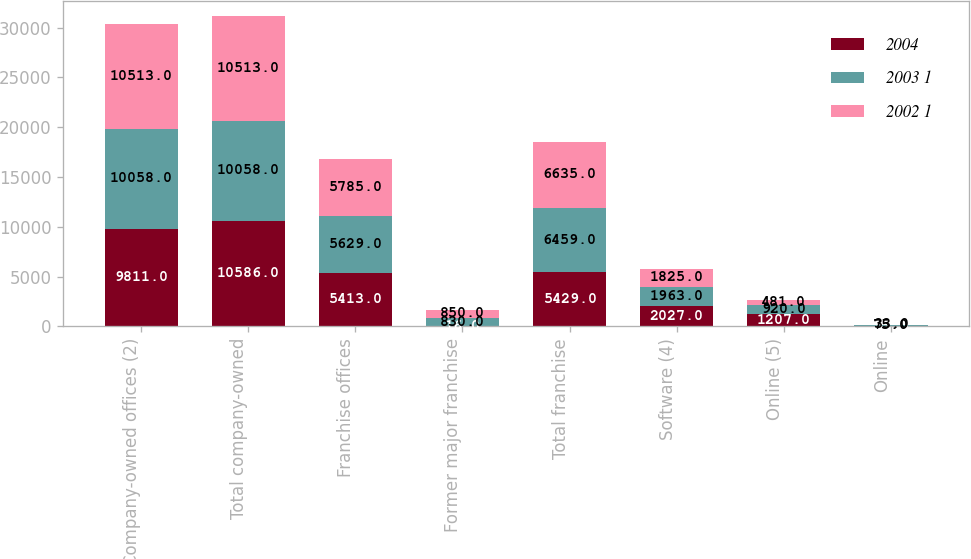Convert chart. <chart><loc_0><loc_0><loc_500><loc_500><stacked_bar_chart><ecel><fcel>Company-owned offices (2)<fcel>Total company-owned<fcel>Franchise offices<fcel>Former major franchise<fcel>Total franchise<fcel>Software (4)<fcel>Online (5)<fcel>Online<nl><fcel>2004<fcel>9811<fcel>10586<fcel>5413<fcel>16<fcel>5429<fcel>2027<fcel>1207<fcel>57<nl><fcel>2003 1<fcel>10058<fcel>10058<fcel>5629<fcel>830<fcel>6459<fcel>1963<fcel>920<fcel>75<nl><fcel>2002 1<fcel>10513<fcel>10513<fcel>5785<fcel>850<fcel>6635<fcel>1825<fcel>481<fcel>33<nl></chart> 